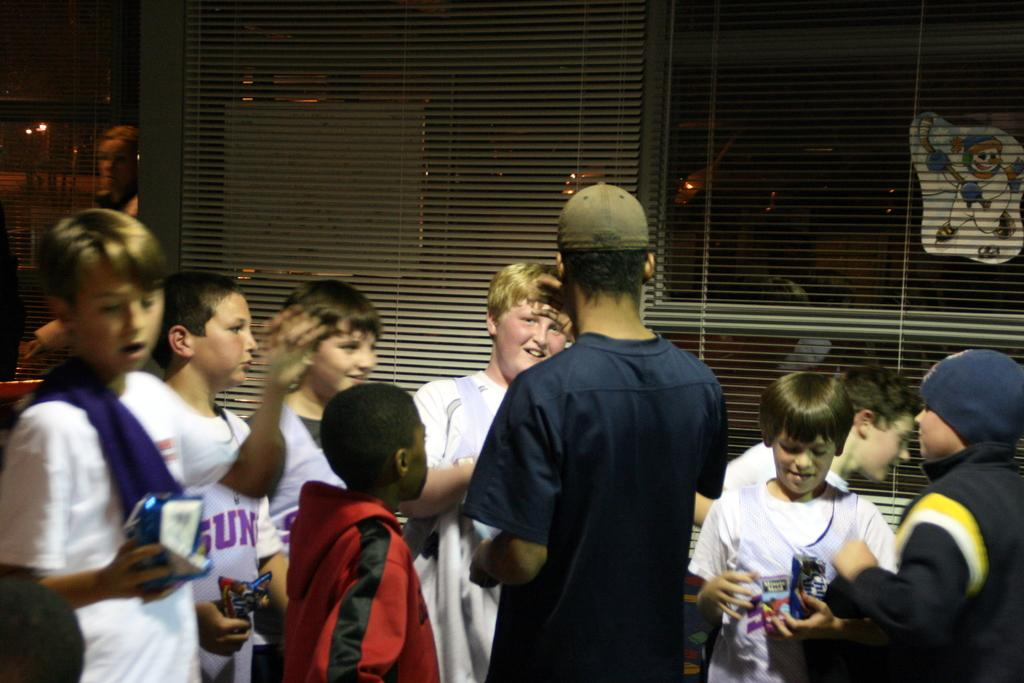What are the people in the image doing? There are people standing in the image. What are the people holding in their hands? Some of the people are holding wrappers. What can be seen in the background of the image? There are blinds visible in the background of the image. Where is the throne located in the image? There is no throne present in the image. What need do the people in the image have that is not being met? The image does not provide information about any unmet needs of the people. 